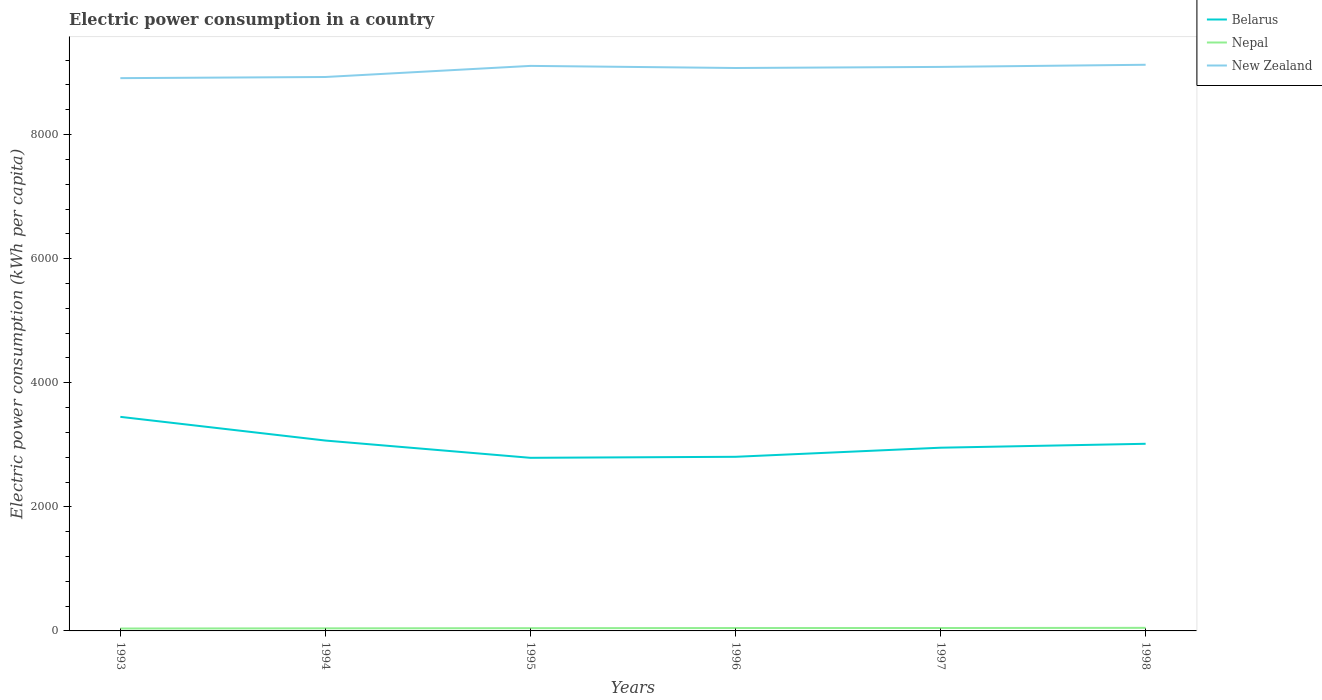How many different coloured lines are there?
Provide a succinct answer. 3. Does the line corresponding to Nepal intersect with the line corresponding to New Zealand?
Make the answer very short. No. Across all years, what is the maximum electric power consumption in in New Zealand?
Keep it short and to the point. 8909.36. What is the total electric power consumption in in New Zealand in the graph?
Provide a short and direct response. -52.15. What is the difference between the highest and the second highest electric power consumption in in Nepal?
Ensure brevity in your answer.  10.8. How many lines are there?
Provide a succinct answer. 3. How many years are there in the graph?
Your response must be concise. 6. Are the values on the major ticks of Y-axis written in scientific E-notation?
Provide a succinct answer. No. Does the graph contain any zero values?
Keep it short and to the point. No. Does the graph contain grids?
Ensure brevity in your answer.  No. What is the title of the graph?
Your response must be concise. Electric power consumption in a country. What is the label or title of the X-axis?
Make the answer very short. Years. What is the label or title of the Y-axis?
Keep it short and to the point. Electric power consumption (kWh per capita). What is the Electric power consumption (kWh per capita) in Belarus in 1993?
Offer a terse response. 3450.24. What is the Electric power consumption (kWh per capita) of Nepal in 1993?
Provide a succinct answer. 38.79. What is the Electric power consumption (kWh per capita) in New Zealand in 1993?
Your answer should be compact. 8909.36. What is the Electric power consumption (kWh per capita) of Belarus in 1994?
Your answer should be compact. 3068.35. What is the Electric power consumption (kWh per capita) in Nepal in 1994?
Your response must be concise. 41.61. What is the Electric power consumption (kWh per capita) of New Zealand in 1994?
Give a very brief answer. 8927.9. What is the Electric power consumption (kWh per capita) in Belarus in 1995?
Your answer should be very brief. 2789.97. What is the Electric power consumption (kWh per capita) of Nepal in 1995?
Make the answer very short. 44.22. What is the Electric power consumption (kWh per capita) in New Zealand in 1995?
Your answer should be very brief. 9106.82. What is the Electric power consumption (kWh per capita) of Belarus in 1996?
Give a very brief answer. 2806.5. What is the Electric power consumption (kWh per capita) in Nepal in 1996?
Give a very brief answer. 46.57. What is the Electric power consumption (kWh per capita) of New Zealand in 1996?
Your answer should be compact. 9072.88. What is the Electric power consumption (kWh per capita) of Belarus in 1997?
Give a very brief answer. 2953.05. What is the Electric power consumption (kWh per capita) in Nepal in 1997?
Ensure brevity in your answer.  46.88. What is the Electric power consumption (kWh per capita) in New Zealand in 1997?
Provide a succinct answer. 9090.52. What is the Electric power consumption (kWh per capita) in Belarus in 1998?
Provide a short and direct response. 3016.29. What is the Electric power consumption (kWh per capita) of Nepal in 1998?
Keep it short and to the point. 49.59. What is the Electric power consumption (kWh per capita) in New Zealand in 1998?
Your answer should be compact. 9125.03. Across all years, what is the maximum Electric power consumption (kWh per capita) in Belarus?
Keep it short and to the point. 3450.24. Across all years, what is the maximum Electric power consumption (kWh per capita) in Nepal?
Keep it short and to the point. 49.59. Across all years, what is the maximum Electric power consumption (kWh per capita) of New Zealand?
Keep it short and to the point. 9125.03. Across all years, what is the minimum Electric power consumption (kWh per capita) of Belarus?
Provide a short and direct response. 2789.97. Across all years, what is the minimum Electric power consumption (kWh per capita) of Nepal?
Your response must be concise. 38.79. Across all years, what is the minimum Electric power consumption (kWh per capita) in New Zealand?
Make the answer very short. 8909.36. What is the total Electric power consumption (kWh per capita) of Belarus in the graph?
Offer a very short reply. 1.81e+04. What is the total Electric power consumption (kWh per capita) of Nepal in the graph?
Keep it short and to the point. 267.68. What is the total Electric power consumption (kWh per capita) in New Zealand in the graph?
Provide a short and direct response. 5.42e+04. What is the difference between the Electric power consumption (kWh per capita) in Belarus in 1993 and that in 1994?
Provide a succinct answer. 381.89. What is the difference between the Electric power consumption (kWh per capita) of Nepal in 1993 and that in 1994?
Ensure brevity in your answer.  -2.82. What is the difference between the Electric power consumption (kWh per capita) of New Zealand in 1993 and that in 1994?
Your response must be concise. -18.55. What is the difference between the Electric power consumption (kWh per capita) of Belarus in 1993 and that in 1995?
Make the answer very short. 660.26. What is the difference between the Electric power consumption (kWh per capita) of Nepal in 1993 and that in 1995?
Your answer should be compact. -5.43. What is the difference between the Electric power consumption (kWh per capita) of New Zealand in 1993 and that in 1995?
Offer a very short reply. -197.47. What is the difference between the Electric power consumption (kWh per capita) of Belarus in 1993 and that in 1996?
Provide a succinct answer. 643.74. What is the difference between the Electric power consumption (kWh per capita) in Nepal in 1993 and that in 1996?
Your answer should be compact. -7.78. What is the difference between the Electric power consumption (kWh per capita) in New Zealand in 1993 and that in 1996?
Make the answer very short. -163.53. What is the difference between the Electric power consumption (kWh per capita) of Belarus in 1993 and that in 1997?
Give a very brief answer. 497.19. What is the difference between the Electric power consumption (kWh per capita) in Nepal in 1993 and that in 1997?
Offer a terse response. -8.09. What is the difference between the Electric power consumption (kWh per capita) in New Zealand in 1993 and that in 1997?
Make the answer very short. -181.17. What is the difference between the Electric power consumption (kWh per capita) of Belarus in 1993 and that in 1998?
Make the answer very short. 433.95. What is the difference between the Electric power consumption (kWh per capita) of Nepal in 1993 and that in 1998?
Offer a very short reply. -10.8. What is the difference between the Electric power consumption (kWh per capita) of New Zealand in 1993 and that in 1998?
Keep it short and to the point. -215.68. What is the difference between the Electric power consumption (kWh per capita) of Belarus in 1994 and that in 1995?
Provide a succinct answer. 278.37. What is the difference between the Electric power consumption (kWh per capita) in Nepal in 1994 and that in 1995?
Give a very brief answer. -2.61. What is the difference between the Electric power consumption (kWh per capita) of New Zealand in 1994 and that in 1995?
Provide a short and direct response. -178.92. What is the difference between the Electric power consumption (kWh per capita) in Belarus in 1994 and that in 1996?
Give a very brief answer. 261.85. What is the difference between the Electric power consumption (kWh per capita) of Nepal in 1994 and that in 1996?
Provide a short and direct response. -4.96. What is the difference between the Electric power consumption (kWh per capita) in New Zealand in 1994 and that in 1996?
Offer a terse response. -144.98. What is the difference between the Electric power consumption (kWh per capita) of Belarus in 1994 and that in 1997?
Your answer should be compact. 115.3. What is the difference between the Electric power consumption (kWh per capita) in Nepal in 1994 and that in 1997?
Keep it short and to the point. -5.27. What is the difference between the Electric power consumption (kWh per capita) of New Zealand in 1994 and that in 1997?
Offer a terse response. -162.62. What is the difference between the Electric power consumption (kWh per capita) of Belarus in 1994 and that in 1998?
Your answer should be compact. 52.06. What is the difference between the Electric power consumption (kWh per capita) of Nepal in 1994 and that in 1998?
Provide a short and direct response. -7.98. What is the difference between the Electric power consumption (kWh per capita) in New Zealand in 1994 and that in 1998?
Ensure brevity in your answer.  -197.13. What is the difference between the Electric power consumption (kWh per capita) in Belarus in 1995 and that in 1996?
Your response must be concise. -16.52. What is the difference between the Electric power consumption (kWh per capita) of Nepal in 1995 and that in 1996?
Provide a succinct answer. -2.35. What is the difference between the Electric power consumption (kWh per capita) of New Zealand in 1995 and that in 1996?
Give a very brief answer. 33.94. What is the difference between the Electric power consumption (kWh per capita) of Belarus in 1995 and that in 1997?
Your answer should be very brief. -163.07. What is the difference between the Electric power consumption (kWh per capita) in Nepal in 1995 and that in 1997?
Keep it short and to the point. -2.66. What is the difference between the Electric power consumption (kWh per capita) of New Zealand in 1995 and that in 1997?
Ensure brevity in your answer.  16.3. What is the difference between the Electric power consumption (kWh per capita) of Belarus in 1995 and that in 1998?
Keep it short and to the point. -226.31. What is the difference between the Electric power consumption (kWh per capita) in Nepal in 1995 and that in 1998?
Keep it short and to the point. -5.37. What is the difference between the Electric power consumption (kWh per capita) of New Zealand in 1995 and that in 1998?
Offer a terse response. -18.21. What is the difference between the Electric power consumption (kWh per capita) in Belarus in 1996 and that in 1997?
Offer a very short reply. -146.55. What is the difference between the Electric power consumption (kWh per capita) in Nepal in 1996 and that in 1997?
Give a very brief answer. -0.32. What is the difference between the Electric power consumption (kWh per capita) in New Zealand in 1996 and that in 1997?
Provide a short and direct response. -17.64. What is the difference between the Electric power consumption (kWh per capita) in Belarus in 1996 and that in 1998?
Offer a very short reply. -209.79. What is the difference between the Electric power consumption (kWh per capita) of Nepal in 1996 and that in 1998?
Provide a succinct answer. -3.02. What is the difference between the Electric power consumption (kWh per capita) of New Zealand in 1996 and that in 1998?
Offer a very short reply. -52.15. What is the difference between the Electric power consumption (kWh per capita) of Belarus in 1997 and that in 1998?
Make the answer very short. -63.24. What is the difference between the Electric power consumption (kWh per capita) of Nepal in 1997 and that in 1998?
Provide a succinct answer. -2.71. What is the difference between the Electric power consumption (kWh per capita) of New Zealand in 1997 and that in 1998?
Provide a short and direct response. -34.51. What is the difference between the Electric power consumption (kWh per capita) of Belarus in 1993 and the Electric power consumption (kWh per capita) of Nepal in 1994?
Provide a short and direct response. 3408.63. What is the difference between the Electric power consumption (kWh per capita) in Belarus in 1993 and the Electric power consumption (kWh per capita) in New Zealand in 1994?
Give a very brief answer. -5477.66. What is the difference between the Electric power consumption (kWh per capita) of Nepal in 1993 and the Electric power consumption (kWh per capita) of New Zealand in 1994?
Your response must be concise. -8889.11. What is the difference between the Electric power consumption (kWh per capita) in Belarus in 1993 and the Electric power consumption (kWh per capita) in Nepal in 1995?
Keep it short and to the point. 3406.01. What is the difference between the Electric power consumption (kWh per capita) in Belarus in 1993 and the Electric power consumption (kWh per capita) in New Zealand in 1995?
Provide a short and direct response. -5656.58. What is the difference between the Electric power consumption (kWh per capita) in Nepal in 1993 and the Electric power consumption (kWh per capita) in New Zealand in 1995?
Give a very brief answer. -9068.03. What is the difference between the Electric power consumption (kWh per capita) in Belarus in 1993 and the Electric power consumption (kWh per capita) in Nepal in 1996?
Keep it short and to the point. 3403.67. What is the difference between the Electric power consumption (kWh per capita) in Belarus in 1993 and the Electric power consumption (kWh per capita) in New Zealand in 1996?
Ensure brevity in your answer.  -5622.64. What is the difference between the Electric power consumption (kWh per capita) in Nepal in 1993 and the Electric power consumption (kWh per capita) in New Zealand in 1996?
Your response must be concise. -9034.09. What is the difference between the Electric power consumption (kWh per capita) in Belarus in 1993 and the Electric power consumption (kWh per capita) in Nepal in 1997?
Make the answer very short. 3403.35. What is the difference between the Electric power consumption (kWh per capita) in Belarus in 1993 and the Electric power consumption (kWh per capita) in New Zealand in 1997?
Provide a short and direct response. -5640.29. What is the difference between the Electric power consumption (kWh per capita) in Nepal in 1993 and the Electric power consumption (kWh per capita) in New Zealand in 1997?
Make the answer very short. -9051.73. What is the difference between the Electric power consumption (kWh per capita) in Belarus in 1993 and the Electric power consumption (kWh per capita) in Nepal in 1998?
Your answer should be very brief. 3400.65. What is the difference between the Electric power consumption (kWh per capita) of Belarus in 1993 and the Electric power consumption (kWh per capita) of New Zealand in 1998?
Provide a short and direct response. -5674.79. What is the difference between the Electric power consumption (kWh per capita) in Nepal in 1993 and the Electric power consumption (kWh per capita) in New Zealand in 1998?
Ensure brevity in your answer.  -9086.24. What is the difference between the Electric power consumption (kWh per capita) in Belarus in 1994 and the Electric power consumption (kWh per capita) in Nepal in 1995?
Keep it short and to the point. 3024.12. What is the difference between the Electric power consumption (kWh per capita) of Belarus in 1994 and the Electric power consumption (kWh per capita) of New Zealand in 1995?
Your answer should be very brief. -6038.47. What is the difference between the Electric power consumption (kWh per capita) of Nepal in 1994 and the Electric power consumption (kWh per capita) of New Zealand in 1995?
Your answer should be compact. -9065.21. What is the difference between the Electric power consumption (kWh per capita) of Belarus in 1994 and the Electric power consumption (kWh per capita) of Nepal in 1996?
Provide a short and direct response. 3021.78. What is the difference between the Electric power consumption (kWh per capita) in Belarus in 1994 and the Electric power consumption (kWh per capita) in New Zealand in 1996?
Give a very brief answer. -6004.53. What is the difference between the Electric power consumption (kWh per capita) of Nepal in 1994 and the Electric power consumption (kWh per capita) of New Zealand in 1996?
Offer a terse response. -9031.27. What is the difference between the Electric power consumption (kWh per capita) in Belarus in 1994 and the Electric power consumption (kWh per capita) in Nepal in 1997?
Provide a succinct answer. 3021.46. What is the difference between the Electric power consumption (kWh per capita) in Belarus in 1994 and the Electric power consumption (kWh per capita) in New Zealand in 1997?
Your answer should be compact. -6022.18. What is the difference between the Electric power consumption (kWh per capita) in Nepal in 1994 and the Electric power consumption (kWh per capita) in New Zealand in 1997?
Keep it short and to the point. -9048.91. What is the difference between the Electric power consumption (kWh per capita) in Belarus in 1994 and the Electric power consumption (kWh per capita) in Nepal in 1998?
Provide a short and direct response. 3018.76. What is the difference between the Electric power consumption (kWh per capita) of Belarus in 1994 and the Electric power consumption (kWh per capita) of New Zealand in 1998?
Give a very brief answer. -6056.68. What is the difference between the Electric power consumption (kWh per capita) in Nepal in 1994 and the Electric power consumption (kWh per capita) in New Zealand in 1998?
Provide a short and direct response. -9083.42. What is the difference between the Electric power consumption (kWh per capita) of Belarus in 1995 and the Electric power consumption (kWh per capita) of Nepal in 1996?
Give a very brief answer. 2743.4. What is the difference between the Electric power consumption (kWh per capita) of Belarus in 1995 and the Electric power consumption (kWh per capita) of New Zealand in 1996?
Provide a succinct answer. -6282.91. What is the difference between the Electric power consumption (kWh per capita) of Nepal in 1995 and the Electric power consumption (kWh per capita) of New Zealand in 1996?
Offer a terse response. -9028.66. What is the difference between the Electric power consumption (kWh per capita) of Belarus in 1995 and the Electric power consumption (kWh per capita) of Nepal in 1997?
Your answer should be compact. 2743.09. What is the difference between the Electric power consumption (kWh per capita) in Belarus in 1995 and the Electric power consumption (kWh per capita) in New Zealand in 1997?
Give a very brief answer. -6300.55. What is the difference between the Electric power consumption (kWh per capita) of Nepal in 1995 and the Electric power consumption (kWh per capita) of New Zealand in 1997?
Ensure brevity in your answer.  -9046.3. What is the difference between the Electric power consumption (kWh per capita) in Belarus in 1995 and the Electric power consumption (kWh per capita) in Nepal in 1998?
Offer a terse response. 2740.38. What is the difference between the Electric power consumption (kWh per capita) in Belarus in 1995 and the Electric power consumption (kWh per capita) in New Zealand in 1998?
Keep it short and to the point. -6335.06. What is the difference between the Electric power consumption (kWh per capita) of Nepal in 1995 and the Electric power consumption (kWh per capita) of New Zealand in 1998?
Ensure brevity in your answer.  -9080.81. What is the difference between the Electric power consumption (kWh per capita) in Belarus in 1996 and the Electric power consumption (kWh per capita) in Nepal in 1997?
Your answer should be very brief. 2759.61. What is the difference between the Electric power consumption (kWh per capita) of Belarus in 1996 and the Electric power consumption (kWh per capita) of New Zealand in 1997?
Offer a terse response. -6284.03. What is the difference between the Electric power consumption (kWh per capita) in Nepal in 1996 and the Electric power consumption (kWh per capita) in New Zealand in 1997?
Your answer should be very brief. -9043.95. What is the difference between the Electric power consumption (kWh per capita) in Belarus in 1996 and the Electric power consumption (kWh per capita) in Nepal in 1998?
Offer a very short reply. 2756.9. What is the difference between the Electric power consumption (kWh per capita) of Belarus in 1996 and the Electric power consumption (kWh per capita) of New Zealand in 1998?
Your answer should be very brief. -6318.54. What is the difference between the Electric power consumption (kWh per capita) in Nepal in 1996 and the Electric power consumption (kWh per capita) in New Zealand in 1998?
Ensure brevity in your answer.  -9078.46. What is the difference between the Electric power consumption (kWh per capita) of Belarus in 1997 and the Electric power consumption (kWh per capita) of Nepal in 1998?
Your answer should be compact. 2903.46. What is the difference between the Electric power consumption (kWh per capita) of Belarus in 1997 and the Electric power consumption (kWh per capita) of New Zealand in 1998?
Make the answer very short. -6171.98. What is the difference between the Electric power consumption (kWh per capita) in Nepal in 1997 and the Electric power consumption (kWh per capita) in New Zealand in 1998?
Your response must be concise. -9078.15. What is the average Electric power consumption (kWh per capita) of Belarus per year?
Keep it short and to the point. 3014.07. What is the average Electric power consumption (kWh per capita) in Nepal per year?
Your response must be concise. 44.61. What is the average Electric power consumption (kWh per capita) of New Zealand per year?
Provide a succinct answer. 9038.75. In the year 1993, what is the difference between the Electric power consumption (kWh per capita) in Belarus and Electric power consumption (kWh per capita) in Nepal?
Your answer should be compact. 3411.45. In the year 1993, what is the difference between the Electric power consumption (kWh per capita) of Belarus and Electric power consumption (kWh per capita) of New Zealand?
Ensure brevity in your answer.  -5459.12. In the year 1993, what is the difference between the Electric power consumption (kWh per capita) of Nepal and Electric power consumption (kWh per capita) of New Zealand?
Your answer should be compact. -8870.56. In the year 1994, what is the difference between the Electric power consumption (kWh per capita) of Belarus and Electric power consumption (kWh per capita) of Nepal?
Offer a very short reply. 3026.74. In the year 1994, what is the difference between the Electric power consumption (kWh per capita) in Belarus and Electric power consumption (kWh per capita) in New Zealand?
Offer a terse response. -5859.55. In the year 1994, what is the difference between the Electric power consumption (kWh per capita) in Nepal and Electric power consumption (kWh per capita) in New Zealand?
Keep it short and to the point. -8886.29. In the year 1995, what is the difference between the Electric power consumption (kWh per capita) of Belarus and Electric power consumption (kWh per capita) of Nepal?
Keep it short and to the point. 2745.75. In the year 1995, what is the difference between the Electric power consumption (kWh per capita) in Belarus and Electric power consumption (kWh per capita) in New Zealand?
Your answer should be very brief. -6316.85. In the year 1995, what is the difference between the Electric power consumption (kWh per capita) in Nepal and Electric power consumption (kWh per capita) in New Zealand?
Your answer should be very brief. -9062.6. In the year 1996, what is the difference between the Electric power consumption (kWh per capita) in Belarus and Electric power consumption (kWh per capita) in Nepal?
Your answer should be compact. 2759.93. In the year 1996, what is the difference between the Electric power consumption (kWh per capita) of Belarus and Electric power consumption (kWh per capita) of New Zealand?
Offer a terse response. -6266.39. In the year 1996, what is the difference between the Electric power consumption (kWh per capita) in Nepal and Electric power consumption (kWh per capita) in New Zealand?
Provide a succinct answer. -9026.31. In the year 1997, what is the difference between the Electric power consumption (kWh per capita) in Belarus and Electric power consumption (kWh per capita) in Nepal?
Your answer should be very brief. 2906.16. In the year 1997, what is the difference between the Electric power consumption (kWh per capita) in Belarus and Electric power consumption (kWh per capita) in New Zealand?
Provide a succinct answer. -6137.48. In the year 1997, what is the difference between the Electric power consumption (kWh per capita) of Nepal and Electric power consumption (kWh per capita) of New Zealand?
Your response must be concise. -9043.64. In the year 1998, what is the difference between the Electric power consumption (kWh per capita) in Belarus and Electric power consumption (kWh per capita) in Nepal?
Provide a short and direct response. 2966.7. In the year 1998, what is the difference between the Electric power consumption (kWh per capita) in Belarus and Electric power consumption (kWh per capita) in New Zealand?
Ensure brevity in your answer.  -6108.75. In the year 1998, what is the difference between the Electric power consumption (kWh per capita) in Nepal and Electric power consumption (kWh per capita) in New Zealand?
Give a very brief answer. -9075.44. What is the ratio of the Electric power consumption (kWh per capita) of Belarus in 1993 to that in 1994?
Offer a very short reply. 1.12. What is the ratio of the Electric power consumption (kWh per capita) of Nepal in 1993 to that in 1994?
Your answer should be very brief. 0.93. What is the ratio of the Electric power consumption (kWh per capita) in New Zealand in 1993 to that in 1994?
Your answer should be very brief. 1. What is the ratio of the Electric power consumption (kWh per capita) of Belarus in 1993 to that in 1995?
Offer a terse response. 1.24. What is the ratio of the Electric power consumption (kWh per capita) in Nepal in 1993 to that in 1995?
Keep it short and to the point. 0.88. What is the ratio of the Electric power consumption (kWh per capita) in New Zealand in 1993 to that in 1995?
Your answer should be very brief. 0.98. What is the ratio of the Electric power consumption (kWh per capita) of Belarus in 1993 to that in 1996?
Ensure brevity in your answer.  1.23. What is the ratio of the Electric power consumption (kWh per capita) in Nepal in 1993 to that in 1996?
Your answer should be very brief. 0.83. What is the ratio of the Electric power consumption (kWh per capita) of Belarus in 1993 to that in 1997?
Keep it short and to the point. 1.17. What is the ratio of the Electric power consumption (kWh per capita) in Nepal in 1993 to that in 1997?
Ensure brevity in your answer.  0.83. What is the ratio of the Electric power consumption (kWh per capita) in New Zealand in 1993 to that in 1997?
Make the answer very short. 0.98. What is the ratio of the Electric power consumption (kWh per capita) of Belarus in 1993 to that in 1998?
Your answer should be compact. 1.14. What is the ratio of the Electric power consumption (kWh per capita) in Nepal in 1993 to that in 1998?
Keep it short and to the point. 0.78. What is the ratio of the Electric power consumption (kWh per capita) of New Zealand in 1993 to that in 1998?
Offer a very short reply. 0.98. What is the ratio of the Electric power consumption (kWh per capita) of Belarus in 1994 to that in 1995?
Your answer should be very brief. 1.1. What is the ratio of the Electric power consumption (kWh per capita) in Nepal in 1994 to that in 1995?
Your answer should be very brief. 0.94. What is the ratio of the Electric power consumption (kWh per capita) of New Zealand in 1994 to that in 1995?
Your answer should be compact. 0.98. What is the ratio of the Electric power consumption (kWh per capita) of Belarus in 1994 to that in 1996?
Ensure brevity in your answer.  1.09. What is the ratio of the Electric power consumption (kWh per capita) in Nepal in 1994 to that in 1996?
Provide a short and direct response. 0.89. What is the ratio of the Electric power consumption (kWh per capita) of New Zealand in 1994 to that in 1996?
Offer a very short reply. 0.98. What is the ratio of the Electric power consumption (kWh per capita) of Belarus in 1994 to that in 1997?
Offer a very short reply. 1.04. What is the ratio of the Electric power consumption (kWh per capita) in Nepal in 1994 to that in 1997?
Ensure brevity in your answer.  0.89. What is the ratio of the Electric power consumption (kWh per capita) in New Zealand in 1994 to that in 1997?
Keep it short and to the point. 0.98. What is the ratio of the Electric power consumption (kWh per capita) of Belarus in 1994 to that in 1998?
Keep it short and to the point. 1.02. What is the ratio of the Electric power consumption (kWh per capita) in Nepal in 1994 to that in 1998?
Make the answer very short. 0.84. What is the ratio of the Electric power consumption (kWh per capita) in New Zealand in 1994 to that in 1998?
Ensure brevity in your answer.  0.98. What is the ratio of the Electric power consumption (kWh per capita) of Belarus in 1995 to that in 1996?
Offer a terse response. 0.99. What is the ratio of the Electric power consumption (kWh per capita) of Nepal in 1995 to that in 1996?
Offer a terse response. 0.95. What is the ratio of the Electric power consumption (kWh per capita) of New Zealand in 1995 to that in 1996?
Offer a terse response. 1. What is the ratio of the Electric power consumption (kWh per capita) of Belarus in 1995 to that in 1997?
Your response must be concise. 0.94. What is the ratio of the Electric power consumption (kWh per capita) in Nepal in 1995 to that in 1997?
Ensure brevity in your answer.  0.94. What is the ratio of the Electric power consumption (kWh per capita) of New Zealand in 1995 to that in 1997?
Ensure brevity in your answer.  1. What is the ratio of the Electric power consumption (kWh per capita) of Belarus in 1995 to that in 1998?
Provide a short and direct response. 0.93. What is the ratio of the Electric power consumption (kWh per capita) in Nepal in 1995 to that in 1998?
Provide a succinct answer. 0.89. What is the ratio of the Electric power consumption (kWh per capita) of New Zealand in 1995 to that in 1998?
Provide a succinct answer. 1. What is the ratio of the Electric power consumption (kWh per capita) of Belarus in 1996 to that in 1997?
Offer a terse response. 0.95. What is the ratio of the Electric power consumption (kWh per capita) in Nepal in 1996 to that in 1997?
Make the answer very short. 0.99. What is the ratio of the Electric power consumption (kWh per capita) of New Zealand in 1996 to that in 1997?
Provide a succinct answer. 1. What is the ratio of the Electric power consumption (kWh per capita) of Belarus in 1996 to that in 1998?
Offer a terse response. 0.93. What is the ratio of the Electric power consumption (kWh per capita) of Nepal in 1996 to that in 1998?
Provide a short and direct response. 0.94. What is the ratio of the Electric power consumption (kWh per capita) in Belarus in 1997 to that in 1998?
Your response must be concise. 0.98. What is the ratio of the Electric power consumption (kWh per capita) of Nepal in 1997 to that in 1998?
Your answer should be compact. 0.95. What is the ratio of the Electric power consumption (kWh per capita) of New Zealand in 1997 to that in 1998?
Make the answer very short. 1. What is the difference between the highest and the second highest Electric power consumption (kWh per capita) of Belarus?
Offer a very short reply. 381.89. What is the difference between the highest and the second highest Electric power consumption (kWh per capita) in Nepal?
Provide a succinct answer. 2.71. What is the difference between the highest and the second highest Electric power consumption (kWh per capita) of New Zealand?
Keep it short and to the point. 18.21. What is the difference between the highest and the lowest Electric power consumption (kWh per capita) in Belarus?
Your response must be concise. 660.26. What is the difference between the highest and the lowest Electric power consumption (kWh per capita) in Nepal?
Keep it short and to the point. 10.8. What is the difference between the highest and the lowest Electric power consumption (kWh per capita) of New Zealand?
Offer a terse response. 215.68. 